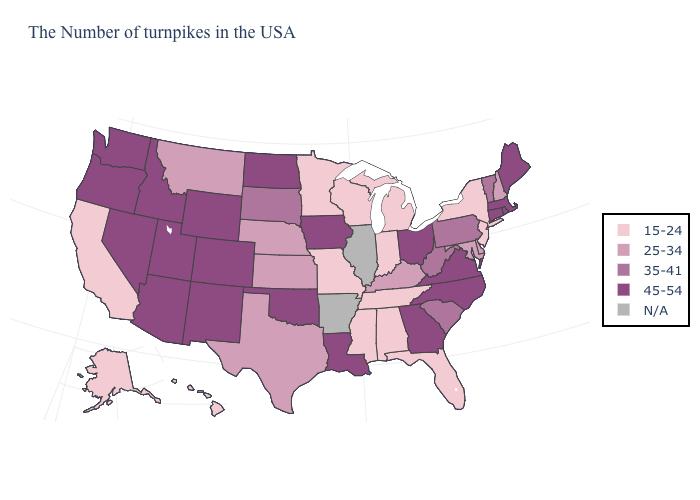Name the states that have a value in the range 15-24?
Quick response, please. New York, New Jersey, Florida, Michigan, Indiana, Alabama, Tennessee, Wisconsin, Mississippi, Missouri, Minnesota, California, Alaska, Hawaii. What is the value of Missouri?
Keep it brief. 15-24. How many symbols are there in the legend?
Give a very brief answer. 5. What is the highest value in the West ?
Short answer required. 45-54. Among the states that border Illinois , does Iowa have the highest value?
Be succinct. Yes. Does Rhode Island have the lowest value in the Northeast?
Short answer required. No. Which states hav the highest value in the MidWest?
Write a very short answer. Ohio, Iowa, North Dakota. Is the legend a continuous bar?
Give a very brief answer. No. What is the highest value in states that border Alabama?
Quick response, please. 45-54. Which states have the lowest value in the MidWest?
Quick response, please. Michigan, Indiana, Wisconsin, Missouri, Minnesota. Which states have the highest value in the USA?
Keep it brief. Maine, Massachusetts, Rhode Island, Connecticut, Virginia, North Carolina, Ohio, Georgia, Louisiana, Iowa, Oklahoma, North Dakota, Wyoming, Colorado, New Mexico, Utah, Arizona, Idaho, Nevada, Washington, Oregon. Does Mississippi have the lowest value in the South?
Concise answer only. Yes. What is the value of Idaho?
Keep it brief. 45-54. 